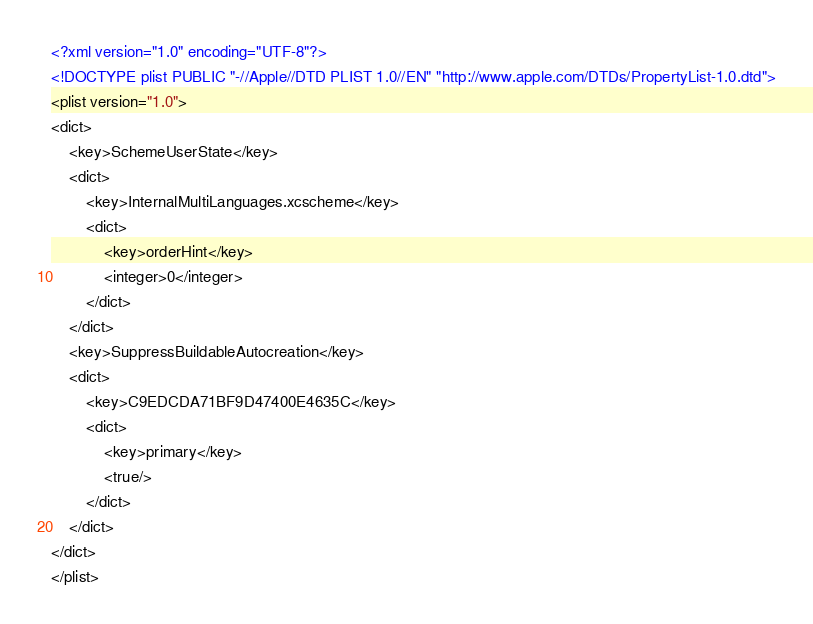<code> <loc_0><loc_0><loc_500><loc_500><_XML_><?xml version="1.0" encoding="UTF-8"?>
<!DOCTYPE plist PUBLIC "-//Apple//DTD PLIST 1.0//EN" "http://www.apple.com/DTDs/PropertyList-1.0.dtd">
<plist version="1.0">
<dict>
	<key>SchemeUserState</key>
	<dict>
		<key>InternalMultiLanguages.xcscheme</key>
		<dict>
			<key>orderHint</key>
			<integer>0</integer>
		</dict>
	</dict>
	<key>SuppressBuildableAutocreation</key>
	<dict>
		<key>C9EDCDA71BF9D47400E4635C</key>
		<dict>
			<key>primary</key>
			<true/>
		</dict>
	</dict>
</dict>
</plist>
</code> 